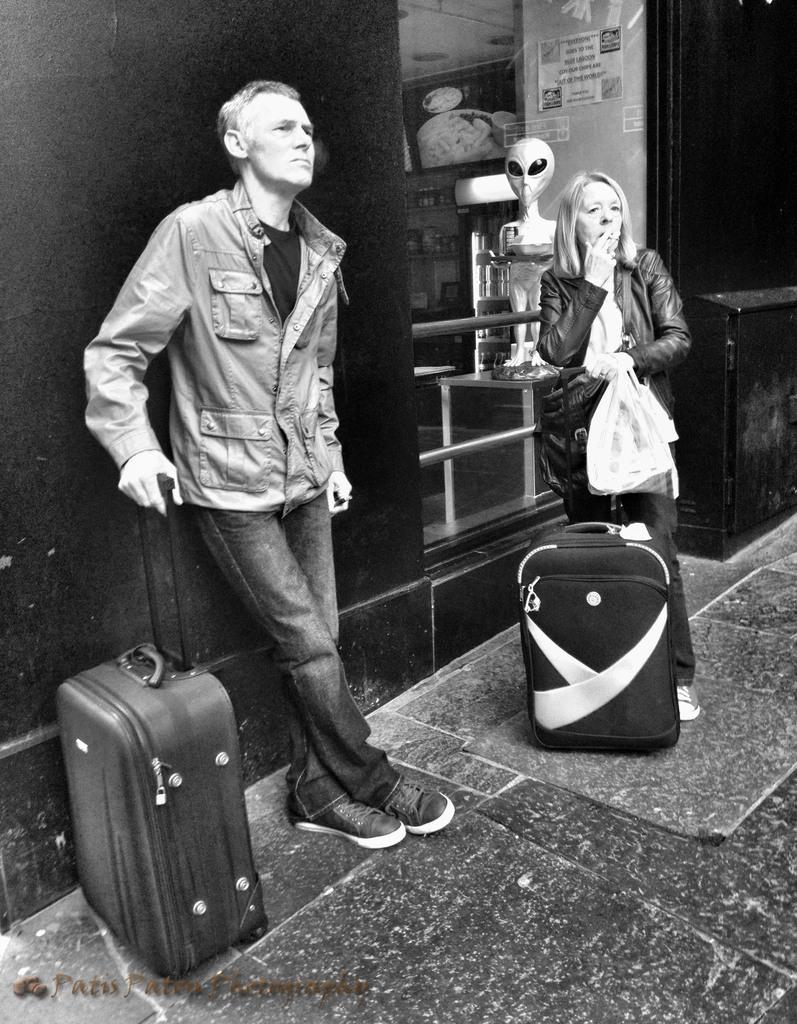What is the man in the image holding? The man is holding a luggage bag in the image. What is the woman in the image holding? The woman is holding a cigarette, a scarf, and a bag in the image. Can you describe the objects in the background of the image? There is a toy visible in the background of the image. How many balloons are tied to the woman's wrist in the image? There are no balloons present in the image. What type of nail is the man using to fix the snail's shell in the image? There is no nail or snail present in the image. 